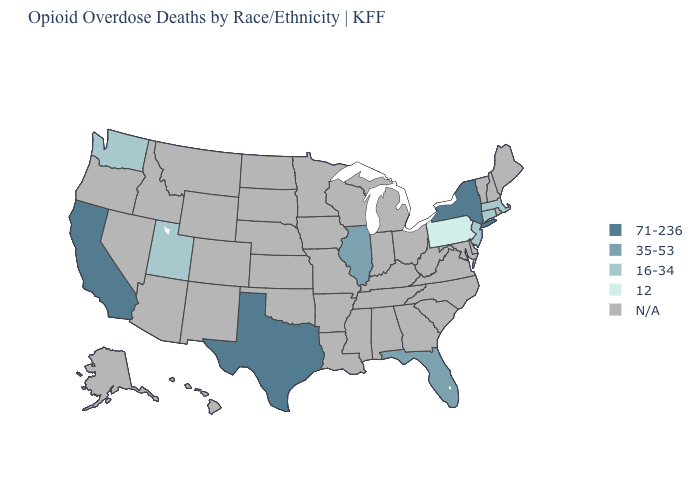What is the lowest value in the USA?
Quick response, please. 12. What is the highest value in the USA?
Answer briefly. 71-236. What is the highest value in the USA?
Give a very brief answer. 71-236. What is the value of Kansas?
Give a very brief answer. N/A. Name the states that have a value in the range N/A?
Concise answer only. Alabama, Alaska, Arizona, Arkansas, Colorado, Delaware, Georgia, Hawaii, Idaho, Indiana, Iowa, Kansas, Kentucky, Louisiana, Maine, Maryland, Michigan, Minnesota, Mississippi, Missouri, Montana, Nebraska, Nevada, New Hampshire, New Mexico, North Carolina, North Dakota, Ohio, Oklahoma, Oregon, Rhode Island, South Carolina, South Dakota, Tennessee, Vermont, Virginia, West Virginia, Wisconsin, Wyoming. Does Massachusetts have the highest value in the USA?
Short answer required. No. Among the states that border New Jersey , does New York have the lowest value?
Short answer required. No. What is the value of Illinois?
Write a very short answer. 35-53. Does the map have missing data?
Give a very brief answer. Yes. What is the value of Massachusetts?
Be succinct. 16-34. What is the value of Alabama?
Be succinct. N/A. Which states hav the highest value in the West?
Give a very brief answer. California. What is the value of Michigan?
Quick response, please. N/A. 